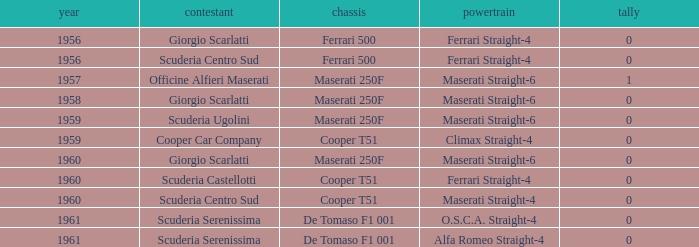Would you be able to parse every entry in this table? {'header': ['year', 'contestant', 'chassis', 'powertrain', 'tally'], 'rows': [['1956', 'Giorgio Scarlatti', 'Ferrari 500', 'Ferrari Straight-4', '0'], ['1956', 'Scuderia Centro Sud', 'Ferrari 500', 'Ferrari Straight-4', '0'], ['1957', 'Officine Alfieri Maserati', 'Maserati 250F', 'Maserati Straight-6', '1'], ['1958', 'Giorgio Scarlatti', 'Maserati 250F', 'Maserati Straight-6', '0'], ['1959', 'Scuderia Ugolini', 'Maserati 250F', 'Maserati Straight-6', '0'], ['1959', 'Cooper Car Company', 'Cooper T51', 'Climax Straight-4', '0'], ['1960', 'Giorgio Scarlatti', 'Maserati 250F', 'Maserati Straight-6', '0'], ['1960', 'Scuderia Castellotti', 'Cooper T51', 'Ferrari Straight-4', '0'], ['1960', 'Scuderia Centro Sud', 'Cooper T51', 'Maserati Straight-4', '0'], ['1961', 'Scuderia Serenissima', 'De Tomaso F1 001', 'O.S.C.A. Straight-4', '0'], ['1961', 'Scuderia Serenissima', 'De Tomaso F1 001', 'Alfa Romeo Straight-4', '0']]} How many points for the cooper car company after 1959? None. 